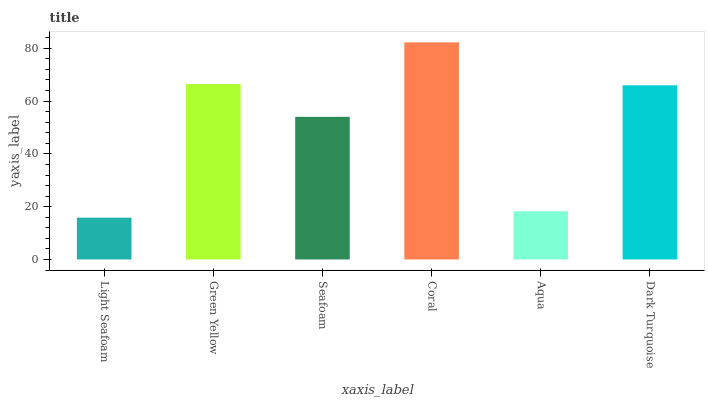Is Green Yellow the minimum?
Answer yes or no. No. Is Green Yellow the maximum?
Answer yes or no. No. Is Green Yellow greater than Light Seafoam?
Answer yes or no. Yes. Is Light Seafoam less than Green Yellow?
Answer yes or no. Yes. Is Light Seafoam greater than Green Yellow?
Answer yes or no. No. Is Green Yellow less than Light Seafoam?
Answer yes or no. No. Is Dark Turquoise the high median?
Answer yes or no. Yes. Is Seafoam the low median?
Answer yes or no. Yes. Is Aqua the high median?
Answer yes or no. No. Is Green Yellow the low median?
Answer yes or no. No. 